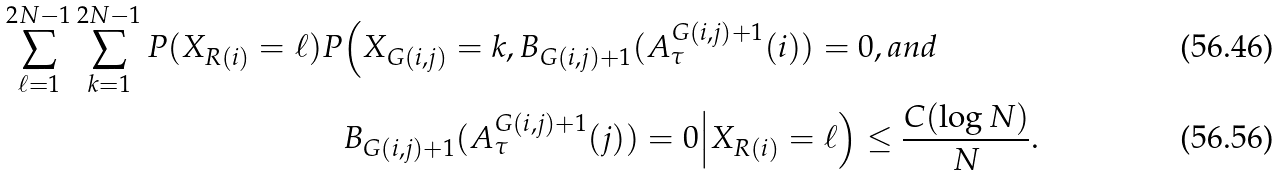Convert formula to latex. <formula><loc_0><loc_0><loc_500><loc_500>\sum _ { \ell = 1 } ^ { 2 N - 1 } \sum _ { k = 1 } ^ { 2 N - 1 } P ( X _ { R ( i ) } = \ell ) P & \Big ( X _ { G ( i , j ) } = k , B _ { G ( i , j ) + 1 } ( A _ { \tau } ^ { G ( i , j ) + 1 } ( i ) ) = 0 , a n d \\ & B _ { G ( i , j ) + 1 } ( A _ { \tau } ^ { G ( i , j ) + 1 } ( j ) ) = 0 \Big | X _ { R ( i ) } = \ell \Big ) \leq \frac { C ( \log N ) } { N } .</formula> 